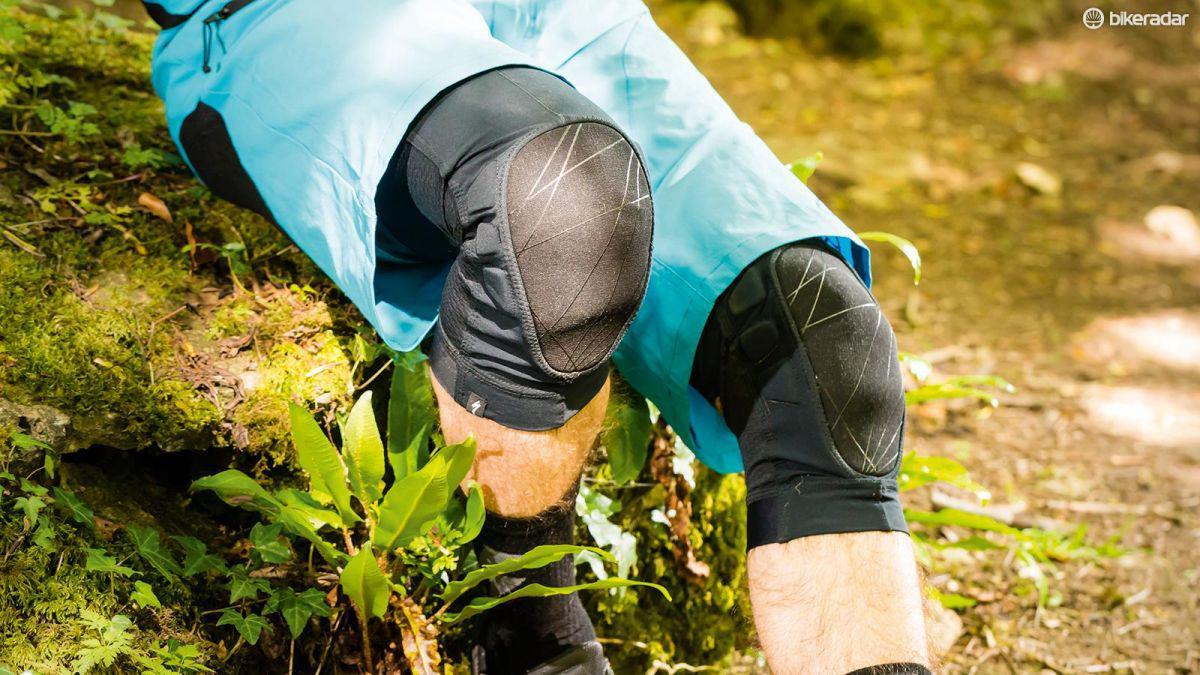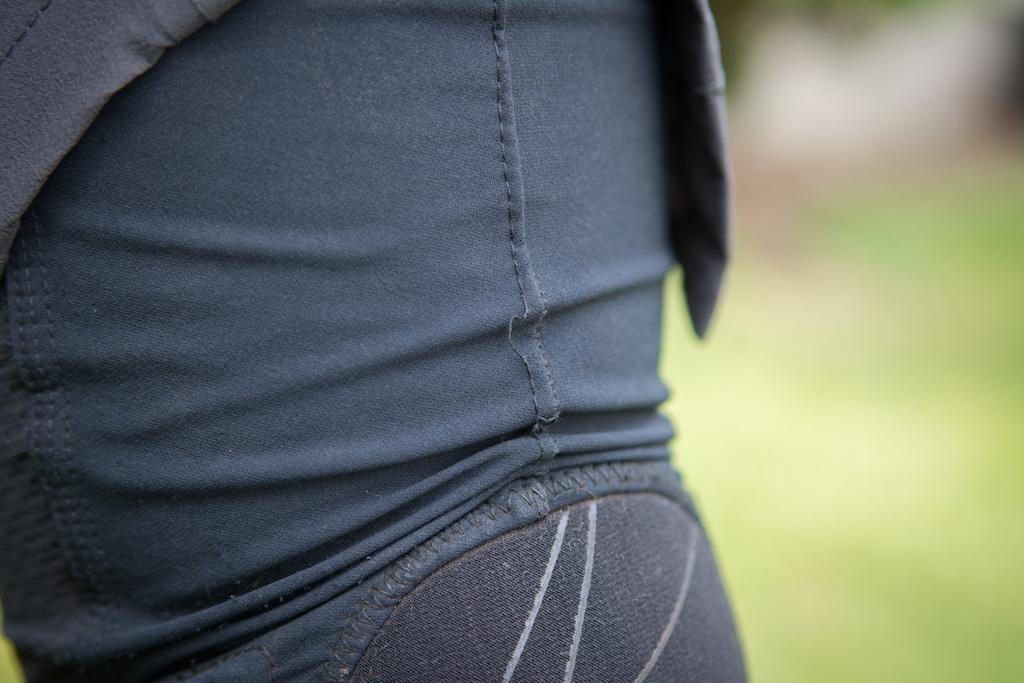The first image is the image on the left, the second image is the image on the right. Analyze the images presented: Is the assertion "One of the knees in the image on the left is bent greater than ninety degrees." valid? Answer yes or no. Yes. 